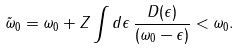<formula> <loc_0><loc_0><loc_500><loc_500>\tilde { \omega } _ { 0 } = \omega _ { 0 } + Z \int d \epsilon \, \frac { D ( \epsilon ) } { ( \omega _ { 0 } - \epsilon ) } < \omega _ { 0 } .</formula> 